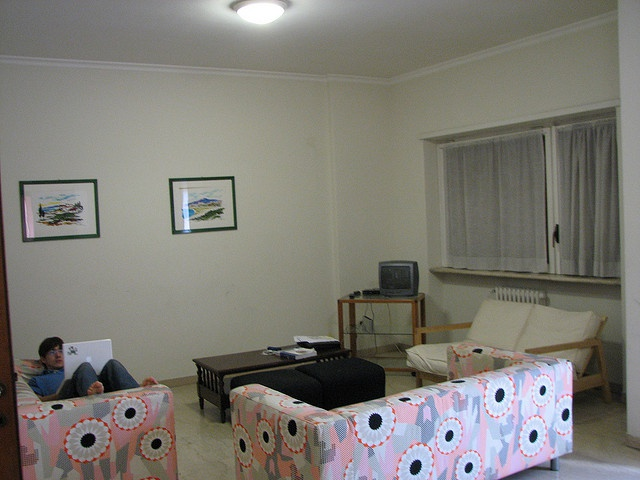Describe the objects in this image and their specific colors. I can see couch in gray, lavender, and darkgray tones, couch in gray and black tones, couch in gray and olive tones, people in gray, black, navy, and maroon tones, and laptop in gray, darkgray, black, and navy tones in this image. 